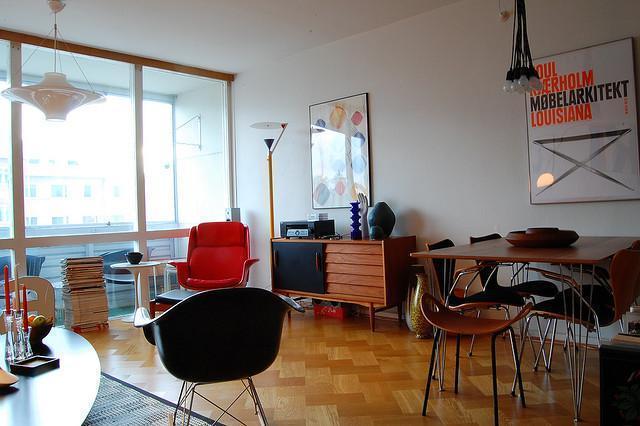What is next to the table on the left?
From the following set of four choices, select the accurate answer to respond to the question.
Options: Green chair, black chair, baby, cow. Black chair. 